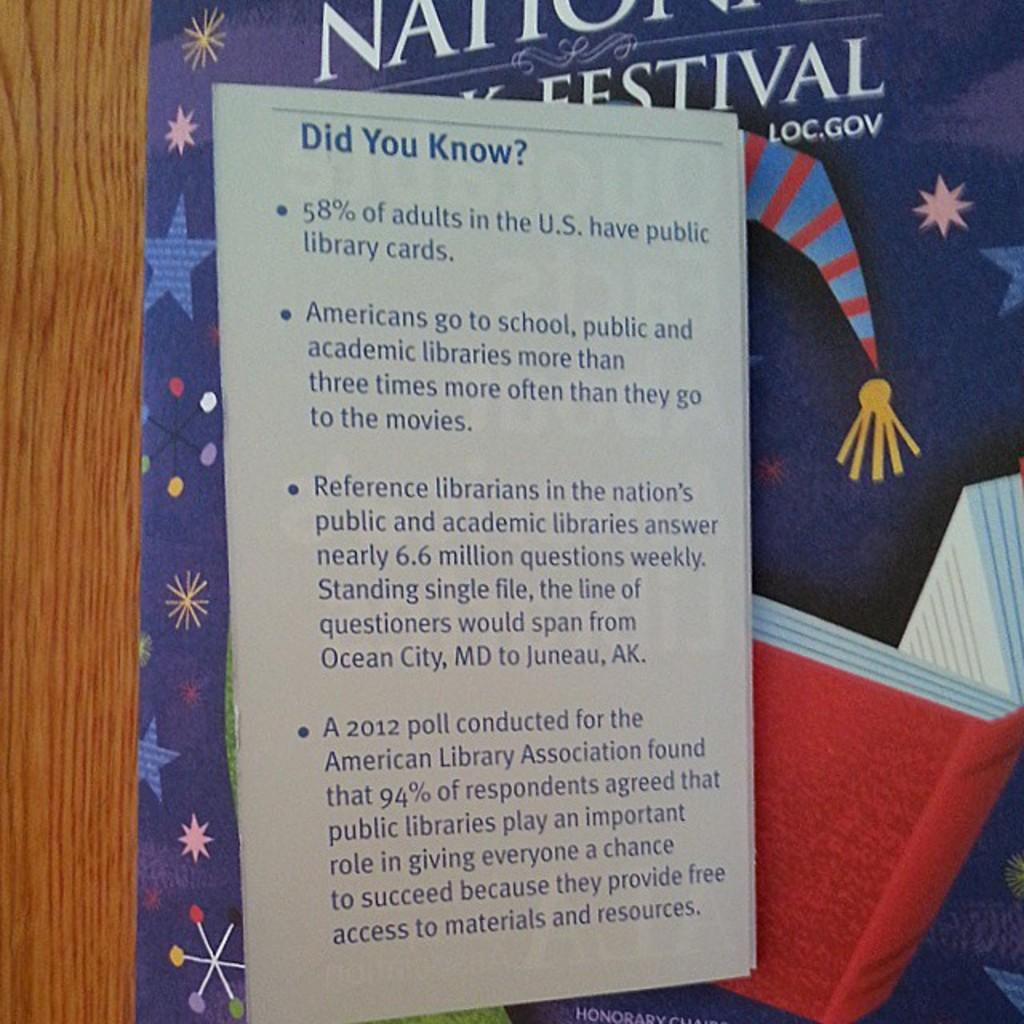Provide a one-sentence caption for the provided image. a poster saying Did you Know in front of a blue and red striped hat picture. 